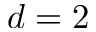<formula> <loc_0><loc_0><loc_500><loc_500>d = 2</formula> 